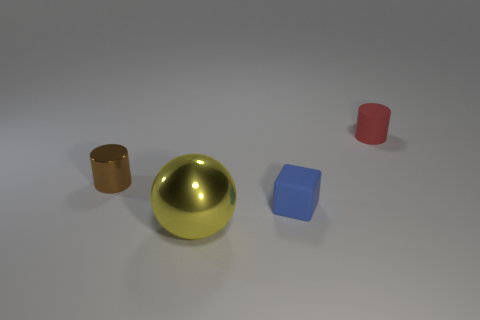Add 2 purple matte cylinders. How many objects exist? 6 Subtract 1 cylinders. How many cylinders are left? 1 Subtract all cubes. How many objects are left? 3 Subtract all red cylinders. How many cylinders are left? 1 Subtract all large shiny spheres. Subtract all small red matte cylinders. How many objects are left? 2 Add 1 big things. How many big things are left? 2 Add 4 gray rubber things. How many gray rubber things exist? 4 Subtract 0 red balls. How many objects are left? 4 Subtract all green balls. Subtract all green cylinders. How many balls are left? 1 